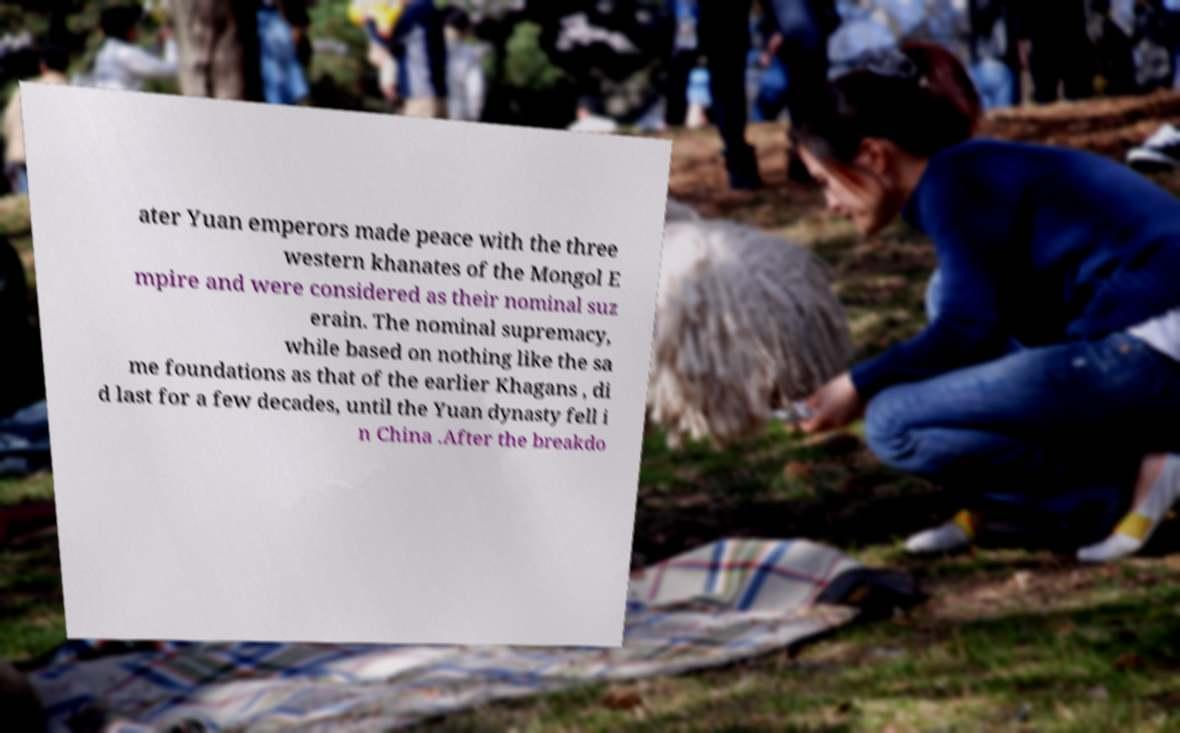I need the written content from this picture converted into text. Can you do that? ater Yuan emperors made peace with the three western khanates of the Mongol E mpire and were considered as their nominal suz erain. The nominal supremacy, while based on nothing like the sa me foundations as that of the earlier Khagans , di d last for a few decades, until the Yuan dynasty fell i n China .After the breakdo 